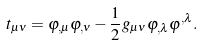<formula> <loc_0><loc_0><loc_500><loc_500>t _ { \mu \nu } = \varphi _ { , \mu } \varphi _ { , \nu } - \frac { 1 } { 2 } g _ { \mu \nu } \varphi _ { , \lambda } \varphi ^ { , \lambda } .</formula> 